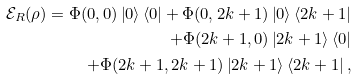Convert formula to latex. <formula><loc_0><loc_0><loc_500><loc_500>\mathcal { E } _ { R } ( \rho ) = \Phi ( 0 , 0 ) \left | 0 \right \rangle \left \langle 0 \right | + \Phi ( 0 , 2 k + 1 ) \left | 0 \right \rangle \left \langle 2 k + 1 \right | \\ + \Phi ( 2 k + 1 , 0 ) \left | 2 k + 1 \right \rangle \left \langle 0 \right | \\ + \Phi ( 2 k + 1 , 2 k + 1 ) \left | 2 k + 1 \right \rangle \left \langle 2 k + 1 \right | ,</formula> 